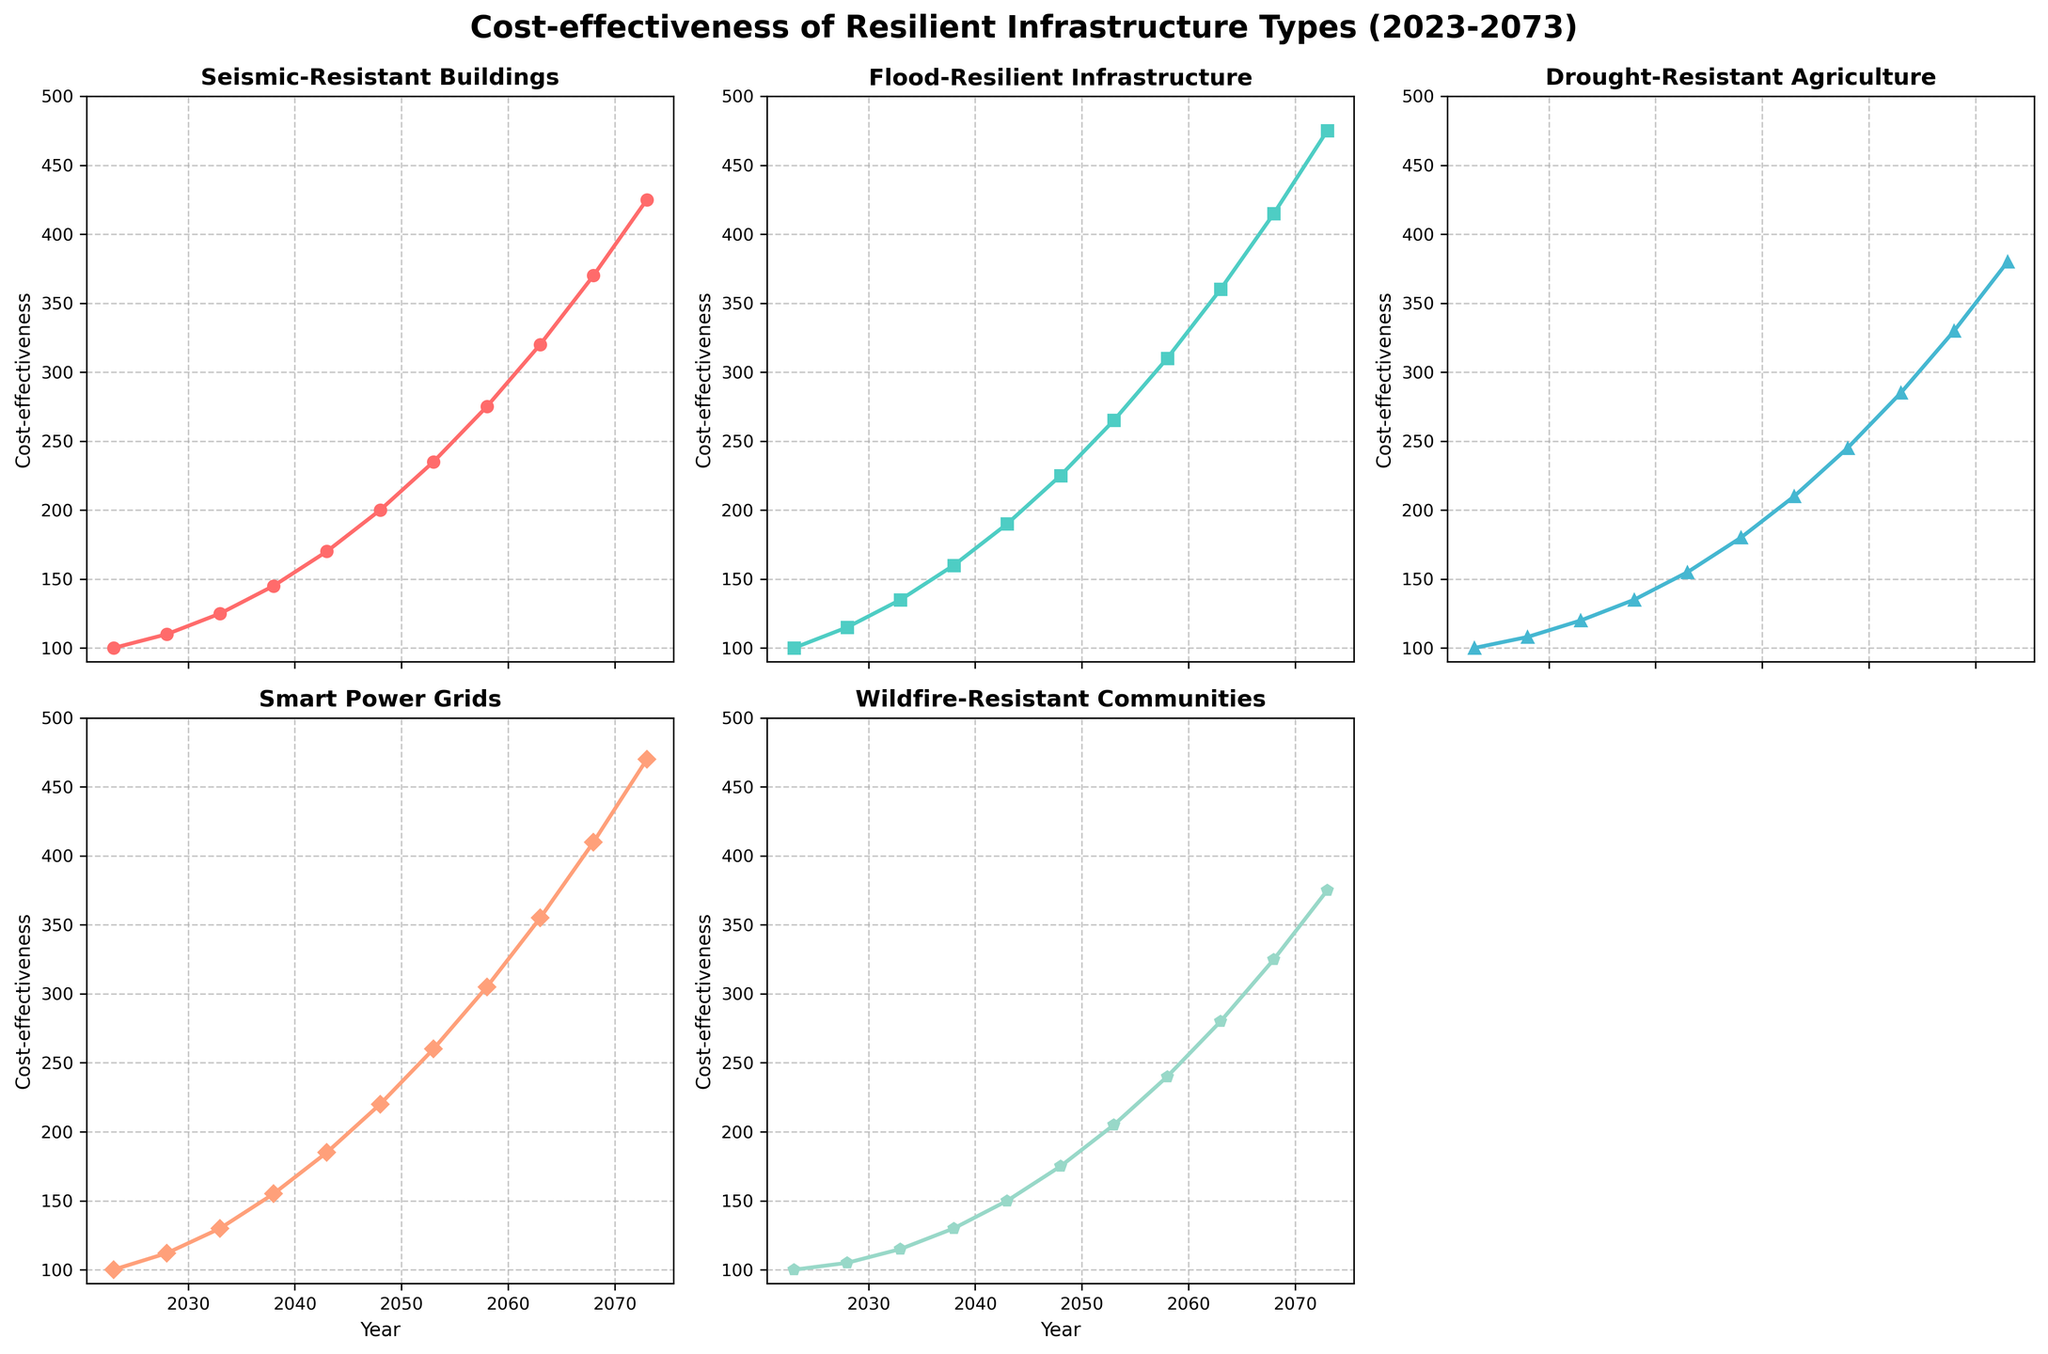What is the title of the figure? The title of the figure is displayed at the top of the plot. It is often in a larger, bold font to indicate the primary subject of the visualization.
Answer: Cost-effectiveness of Resilient Infrastructure Types (2023-2073) What is the cost-effectiveness value for Seismic-Resistant Buildings in 2038? Locate the subplot for "Seismic-Resistant Buildings." Find the data point corresponding to the year 2038 and read the cost-effectiveness value on the y-axis.
Answer: 145 Which resilient infrastructure type shows the highest cost-effectiveness value in 2073? Compare the data points for the year 2073 across all subplots for different resilient infrastructure types and identify the one with the highest value.
Answer: Seismic-Resistant Buildings Between which years does Flood-Resilient Infrastructure have the most significant increase in cost-effectiveness? To determine the most significant increase, calculate the change in cost-effectiveness between consecutive years and identify the largest difference. For Flood-Resilient Infrastructure, note the steepest slope in its line chart.
Answer: 2068 to 2073 What is the average cost-effectiveness for Wildfire-Resistant Communities from 2023 to 2043? Sum the cost-effectiveness values for Wildfire-Resistant Communities from 2023 to 2043 and divide by the number of data points (5). (100 + 105 + 115 + 130 + 150) / 5 = 120
Answer: 120 Compare the trend of Drought-Resistant Agriculture with Smart Power Grids over the 50 years. Which one shows a steeper increase? Examine the slope of the line plots for both "Drought-Resistant Agriculture" and "Smart Power Grids." A steeper increase is indicated by a more significant upward slope over time.
Answer: Smart Power Grids In which year did Drought-Resistant Agriculture surpass a cost-effectiveness value of 200? Look for the data point in the subplot for "Drought-Resistant Agriculture" where the value first exceeds 200 on the y-axis.
Answer: 2058 How many subplots are presented in the figure? Count the individual line charts, each representing a different type of resilient infrastructure within the figure.
Answer: 5 What is the cost-effectiveness value for Smart Power Grids in 2048 and how does it compare to the cost-effectiveness value for Flood-Resilient Infrastructure in the same year? Locate the values for Smart Power Grids and Flood-Resilient Infrastructure in the year 2048. Smart Power Grids show 220, while Flood-Resilient Infrastructure shows 225. Compare these values.
Answer: Smart Power Grids: 220, Flood-Resilient Infrastructure: 225 